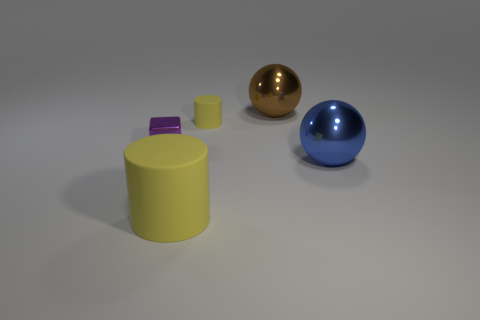What size is the metal thing that is left of the blue thing and in front of the brown sphere?
Offer a very short reply. Small. The big brown object has what shape?
Your response must be concise. Sphere. What number of things are big brown rubber spheres or blue shiny things that are in front of the tiny purple object?
Keep it short and to the point. 1. There is a rubber cylinder that is behind the small cube; is it the same color as the big matte cylinder?
Your answer should be very brief. Yes. What is the color of the big object that is in front of the brown object and behind the large yellow cylinder?
Keep it short and to the point. Blue. There is a big ball in front of the tiny purple shiny object; what material is it?
Your answer should be very brief. Metal. What is the size of the blue sphere?
Ensure brevity in your answer.  Large. How many red objects are either tiny objects or tiny metal cubes?
Provide a short and direct response. 0. What is the size of the object that is to the right of the large shiny object that is behind the small yellow rubber cylinder?
Offer a very short reply. Large. There is a tiny cylinder; does it have the same color as the cylinder in front of the tiny yellow thing?
Offer a very short reply. Yes. 